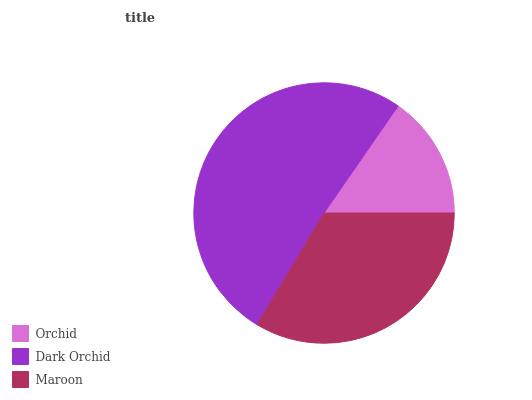Is Orchid the minimum?
Answer yes or no. Yes. Is Dark Orchid the maximum?
Answer yes or no. Yes. Is Maroon the minimum?
Answer yes or no. No. Is Maroon the maximum?
Answer yes or no. No. Is Dark Orchid greater than Maroon?
Answer yes or no. Yes. Is Maroon less than Dark Orchid?
Answer yes or no. Yes. Is Maroon greater than Dark Orchid?
Answer yes or no. No. Is Dark Orchid less than Maroon?
Answer yes or no. No. Is Maroon the high median?
Answer yes or no. Yes. Is Maroon the low median?
Answer yes or no. Yes. Is Dark Orchid the high median?
Answer yes or no. No. Is Dark Orchid the low median?
Answer yes or no. No. 